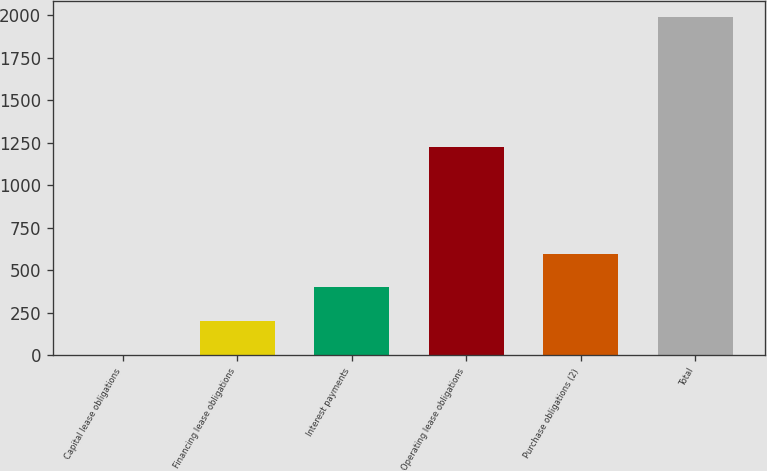Convert chart to OTSL. <chart><loc_0><loc_0><loc_500><loc_500><bar_chart><fcel>Capital lease obligations<fcel>Financing lease obligations<fcel>Interest payments<fcel>Operating lease obligations<fcel>Purchase obligations (2)<fcel>Total<nl><fcel>2<fcel>200.4<fcel>398.8<fcel>1224<fcel>597.2<fcel>1986<nl></chart> 